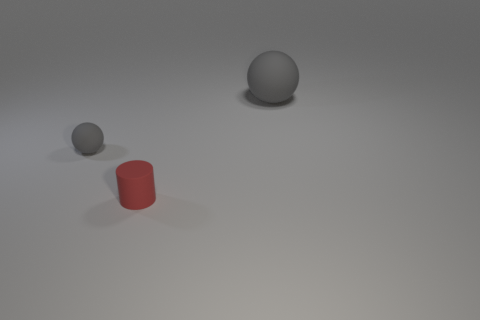What shape is the small matte thing right of the tiny rubber thing left of the small cylinder?
Provide a short and direct response. Cylinder. Are there any other cylinders of the same size as the matte cylinder?
Your answer should be very brief. No. Is the number of rubber balls less than the number of tiny purple rubber cylinders?
Give a very brief answer. No. The small red object left of the rubber sphere behind the tiny gray sphere behind the cylinder is what shape?
Provide a succinct answer. Cylinder. What number of objects are either rubber things that are right of the tiny red matte cylinder or objects that are in front of the big gray matte thing?
Provide a succinct answer. 3. Are there any small red rubber cylinders in front of the tiny gray matte object?
Offer a terse response. Yes. What number of things are either tiny gray matte balls that are behind the red rubber thing or tiny cyan metal cylinders?
Ensure brevity in your answer.  1. What number of gray things are tiny rubber cubes or big rubber objects?
Give a very brief answer. 1. What number of other things are there of the same color as the matte cylinder?
Keep it short and to the point. 0. Is the number of tiny red matte cylinders on the right side of the big ball less than the number of red objects?
Your response must be concise. Yes. 